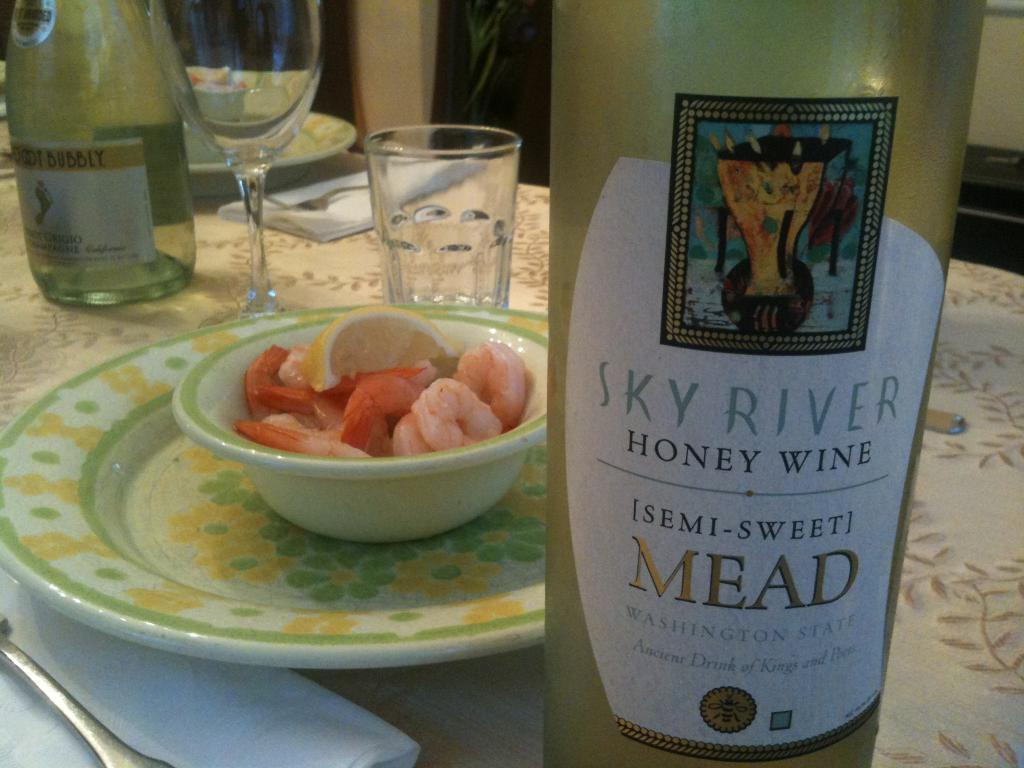Provide a one-sentence caption for the provided image. The diners chose Sky River Honey Wine, Semi-sweet Mead to pair with their shrimp. 